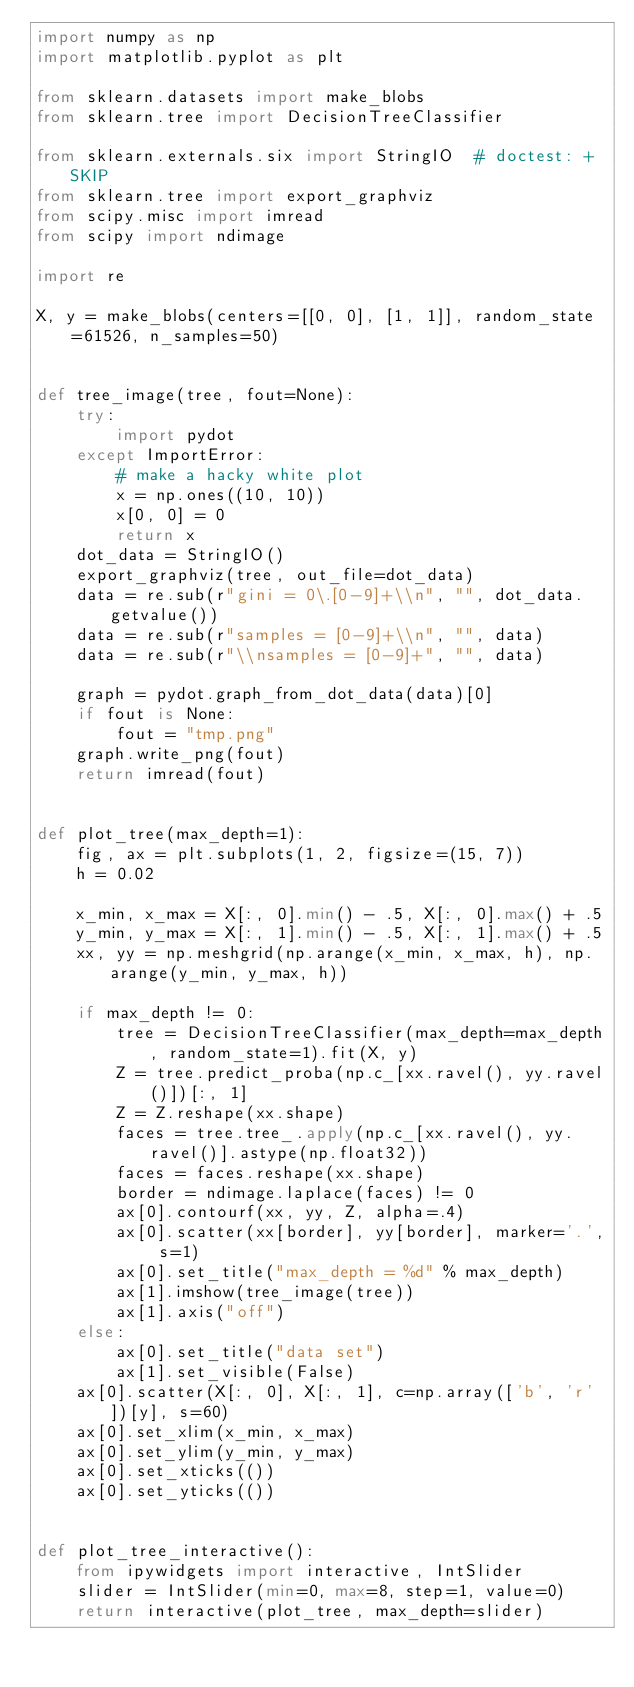Convert code to text. <code><loc_0><loc_0><loc_500><loc_500><_Python_>import numpy as np
import matplotlib.pyplot as plt

from sklearn.datasets import make_blobs
from sklearn.tree import DecisionTreeClassifier

from sklearn.externals.six import StringIO  # doctest: +SKIP
from sklearn.tree import export_graphviz
from scipy.misc import imread
from scipy import ndimage

import re

X, y = make_blobs(centers=[[0, 0], [1, 1]], random_state=61526, n_samples=50)


def tree_image(tree, fout=None):
    try:
        import pydot
    except ImportError:
        # make a hacky white plot
        x = np.ones((10, 10))
        x[0, 0] = 0
        return x
    dot_data = StringIO()
    export_graphviz(tree, out_file=dot_data)
    data = re.sub(r"gini = 0\.[0-9]+\\n", "", dot_data.getvalue())
    data = re.sub(r"samples = [0-9]+\\n", "", data)
    data = re.sub(r"\\nsamples = [0-9]+", "", data)

    graph = pydot.graph_from_dot_data(data)[0]
    if fout is None:
        fout = "tmp.png"
    graph.write_png(fout)
    return imread(fout)


def plot_tree(max_depth=1):
    fig, ax = plt.subplots(1, 2, figsize=(15, 7))
    h = 0.02

    x_min, x_max = X[:, 0].min() - .5, X[:, 0].max() + .5
    y_min, y_max = X[:, 1].min() - .5, X[:, 1].max() + .5
    xx, yy = np.meshgrid(np.arange(x_min, x_max, h), np.arange(y_min, y_max, h))

    if max_depth != 0:
        tree = DecisionTreeClassifier(max_depth=max_depth, random_state=1).fit(X, y)
        Z = tree.predict_proba(np.c_[xx.ravel(), yy.ravel()])[:, 1]
        Z = Z.reshape(xx.shape)
        faces = tree.tree_.apply(np.c_[xx.ravel(), yy.ravel()].astype(np.float32))
        faces = faces.reshape(xx.shape)
        border = ndimage.laplace(faces) != 0
        ax[0].contourf(xx, yy, Z, alpha=.4)
        ax[0].scatter(xx[border], yy[border], marker='.', s=1)
        ax[0].set_title("max_depth = %d" % max_depth)
        ax[1].imshow(tree_image(tree))
        ax[1].axis("off")
    else:
        ax[0].set_title("data set")
        ax[1].set_visible(False)
    ax[0].scatter(X[:, 0], X[:, 1], c=np.array(['b', 'r'])[y], s=60)
    ax[0].set_xlim(x_min, x_max)
    ax[0].set_ylim(y_min, y_max)
    ax[0].set_xticks(())
    ax[0].set_yticks(())


def plot_tree_interactive():
    from ipywidgets import interactive, IntSlider
    slider = IntSlider(min=0, max=8, step=1, value=0)
    return interactive(plot_tree, max_depth=slider)</code> 